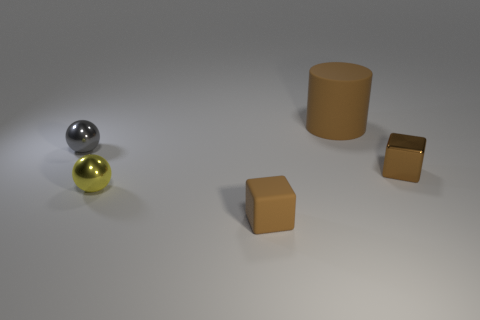Can you explain the lighting in this image? The lighting in the image is soft yet directional, creating subtle shadows that enhance the three-dimensional appearance of the objects. It seems to be coming from the upper left, illuminating the scene uniformly but also highlighting the textures and shapes of different objects effectively. 